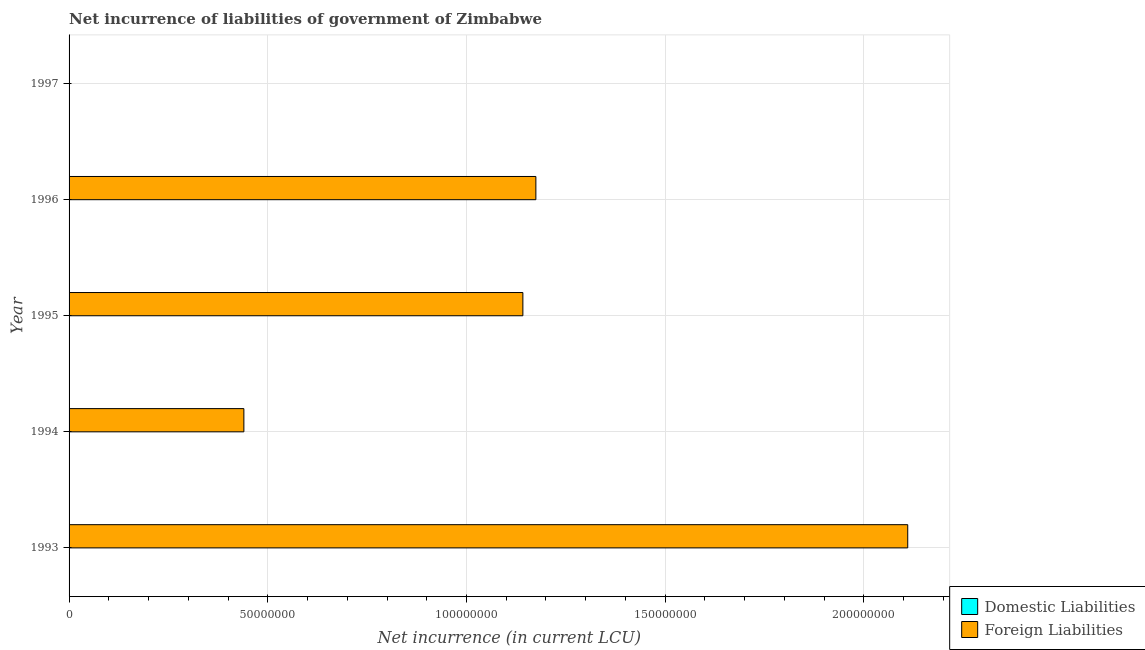Are the number of bars on each tick of the Y-axis equal?
Provide a succinct answer. No. How many bars are there on the 3rd tick from the top?
Offer a terse response. 1. How many bars are there on the 1st tick from the bottom?
Provide a short and direct response. 1. What is the label of the 5th group of bars from the top?
Ensure brevity in your answer.  1993. In how many cases, is the number of bars for a given year not equal to the number of legend labels?
Offer a very short reply. 5. What is the net incurrence of domestic liabilities in 1997?
Give a very brief answer. 0. Across all years, what is the maximum net incurrence of foreign liabilities?
Make the answer very short. 2.11e+08. Across all years, what is the minimum net incurrence of domestic liabilities?
Offer a terse response. 0. In which year was the net incurrence of foreign liabilities maximum?
Provide a short and direct response. 1993. What is the total net incurrence of foreign liabilities in the graph?
Provide a succinct answer. 4.87e+08. What is the difference between the net incurrence of foreign liabilities in 1994 and that in 1995?
Your response must be concise. -7.02e+07. What is the difference between the net incurrence of foreign liabilities in 1994 and the net incurrence of domestic liabilities in 1996?
Provide a short and direct response. 4.40e+07. What is the average net incurrence of domestic liabilities per year?
Your response must be concise. 0. What is the ratio of the net incurrence of foreign liabilities in 1993 to that in 1996?
Ensure brevity in your answer.  1.8. Is the net incurrence of foreign liabilities in 1994 less than that in 1996?
Give a very brief answer. Yes. What is the difference between the highest and the second highest net incurrence of foreign liabilities?
Keep it short and to the point. 9.36e+07. What is the difference between the highest and the lowest net incurrence of foreign liabilities?
Offer a very short reply. 2.11e+08. Is the sum of the net incurrence of foreign liabilities in 1994 and 1996 greater than the maximum net incurrence of domestic liabilities across all years?
Offer a very short reply. Yes. How many bars are there?
Make the answer very short. 4. Are all the bars in the graph horizontal?
Your response must be concise. Yes. How many years are there in the graph?
Provide a short and direct response. 5. What is the difference between two consecutive major ticks on the X-axis?
Provide a succinct answer. 5.00e+07. Does the graph contain grids?
Keep it short and to the point. Yes. What is the title of the graph?
Provide a short and direct response. Net incurrence of liabilities of government of Zimbabwe. What is the label or title of the X-axis?
Provide a short and direct response. Net incurrence (in current LCU). What is the Net incurrence (in current LCU) of Domestic Liabilities in 1993?
Offer a very short reply. 0. What is the Net incurrence (in current LCU) of Foreign Liabilities in 1993?
Give a very brief answer. 2.11e+08. What is the Net incurrence (in current LCU) of Domestic Liabilities in 1994?
Your answer should be very brief. 0. What is the Net incurrence (in current LCU) in Foreign Liabilities in 1994?
Your answer should be very brief. 4.40e+07. What is the Net incurrence (in current LCU) of Domestic Liabilities in 1995?
Your answer should be compact. 0. What is the Net incurrence (in current LCU) of Foreign Liabilities in 1995?
Give a very brief answer. 1.14e+08. What is the Net incurrence (in current LCU) of Domestic Liabilities in 1996?
Offer a very short reply. 0. What is the Net incurrence (in current LCU) in Foreign Liabilities in 1996?
Offer a very short reply. 1.17e+08. What is the Net incurrence (in current LCU) of Domestic Liabilities in 1997?
Offer a terse response. 0. What is the Net incurrence (in current LCU) in Foreign Liabilities in 1997?
Offer a terse response. 0. Across all years, what is the maximum Net incurrence (in current LCU) in Foreign Liabilities?
Provide a succinct answer. 2.11e+08. Across all years, what is the minimum Net incurrence (in current LCU) of Foreign Liabilities?
Give a very brief answer. 0. What is the total Net incurrence (in current LCU) in Foreign Liabilities in the graph?
Provide a short and direct response. 4.87e+08. What is the difference between the Net incurrence (in current LCU) in Foreign Liabilities in 1993 and that in 1994?
Ensure brevity in your answer.  1.67e+08. What is the difference between the Net incurrence (in current LCU) of Foreign Liabilities in 1993 and that in 1995?
Give a very brief answer. 9.68e+07. What is the difference between the Net incurrence (in current LCU) in Foreign Liabilities in 1993 and that in 1996?
Your response must be concise. 9.36e+07. What is the difference between the Net incurrence (in current LCU) of Foreign Liabilities in 1994 and that in 1995?
Provide a succinct answer. -7.02e+07. What is the difference between the Net incurrence (in current LCU) in Foreign Liabilities in 1994 and that in 1996?
Offer a terse response. -7.35e+07. What is the difference between the Net incurrence (in current LCU) of Foreign Liabilities in 1995 and that in 1996?
Provide a short and direct response. -3.27e+06. What is the average Net incurrence (in current LCU) in Domestic Liabilities per year?
Ensure brevity in your answer.  0. What is the average Net incurrence (in current LCU) of Foreign Liabilities per year?
Provide a succinct answer. 9.73e+07. What is the ratio of the Net incurrence (in current LCU) of Foreign Liabilities in 1993 to that in 1994?
Ensure brevity in your answer.  4.8. What is the ratio of the Net incurrence (in current LCU) of Foreign Liabilities in 1993 to that in 1995?
Give a very brief answer. 1.85. What is the ratio of the Net incurrence (in current LCU) of Foreign Liabilities in 1993 to that in 1996?
Ensure brevity in your answer.  1.8. What is the ratio of the Net incurrence (in current LCU) of Foreign Liabilities in 1994 to that in 1995?
Offer a terse response. 0.39. What is the ratio of the Net incurrence (in current LCU) in Foreign Liabilities in 1994 to that in 1996?
Keep it short and to the point. 0.37. What is the ratio of the Net incurrence (in current LCU) in Foreign Liabilities in 1995 to that in 1996?
Make the answer very short. 0.97. What is the difference between the highest and the second highest Net incurrence (in current LCU) of Foreign Liabilities?
Make the answer very short. 9.36e+07. What is the difference between the highest and the lowest Net incurrence (in current LCU) in Foreign Liabilities?
Make the answer very short. 2.11e+08. 